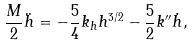<formula> <loc_0><loc_0><loc_500><loc_500>\frac { M } { 2 } \ddot { h } = - \frac { 5 } { 4 } k _ { h } h ^ { 3 / 2 } - \frac { 5 } { 2 } k ^ { \prime \prime } \dot { h } ,</formula> 